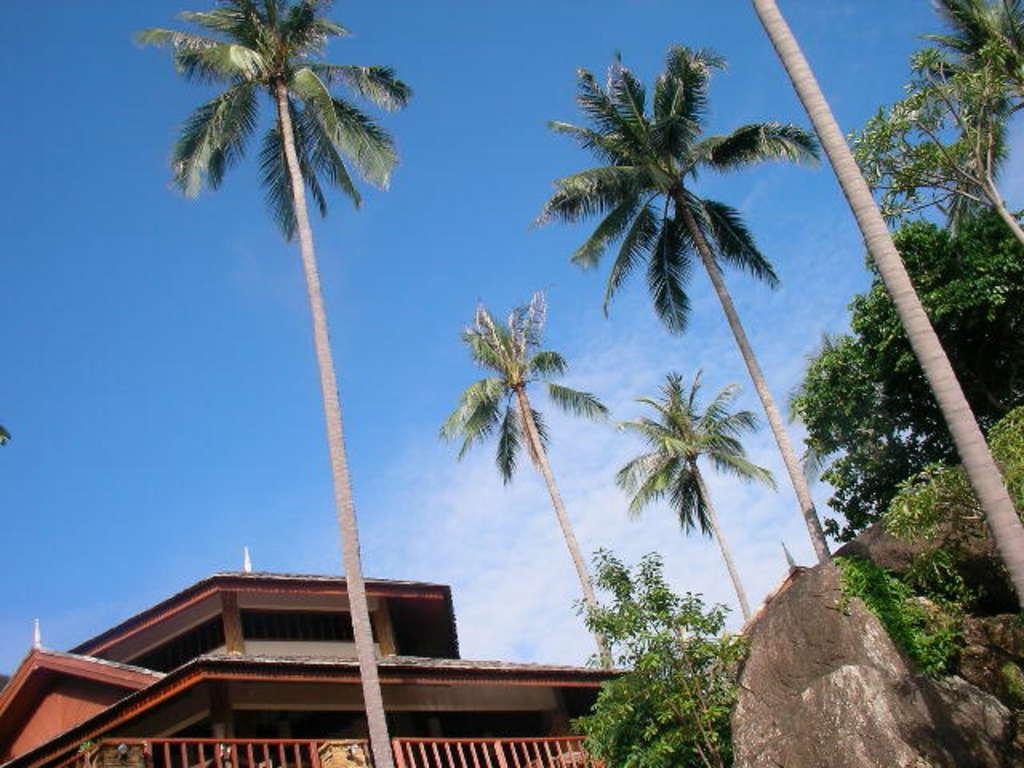Could you give a brief overview of what you see in this image? In this image I can see a huge rock, some grass, few trees and a building which is brown in color. In the background I can see the sky. 